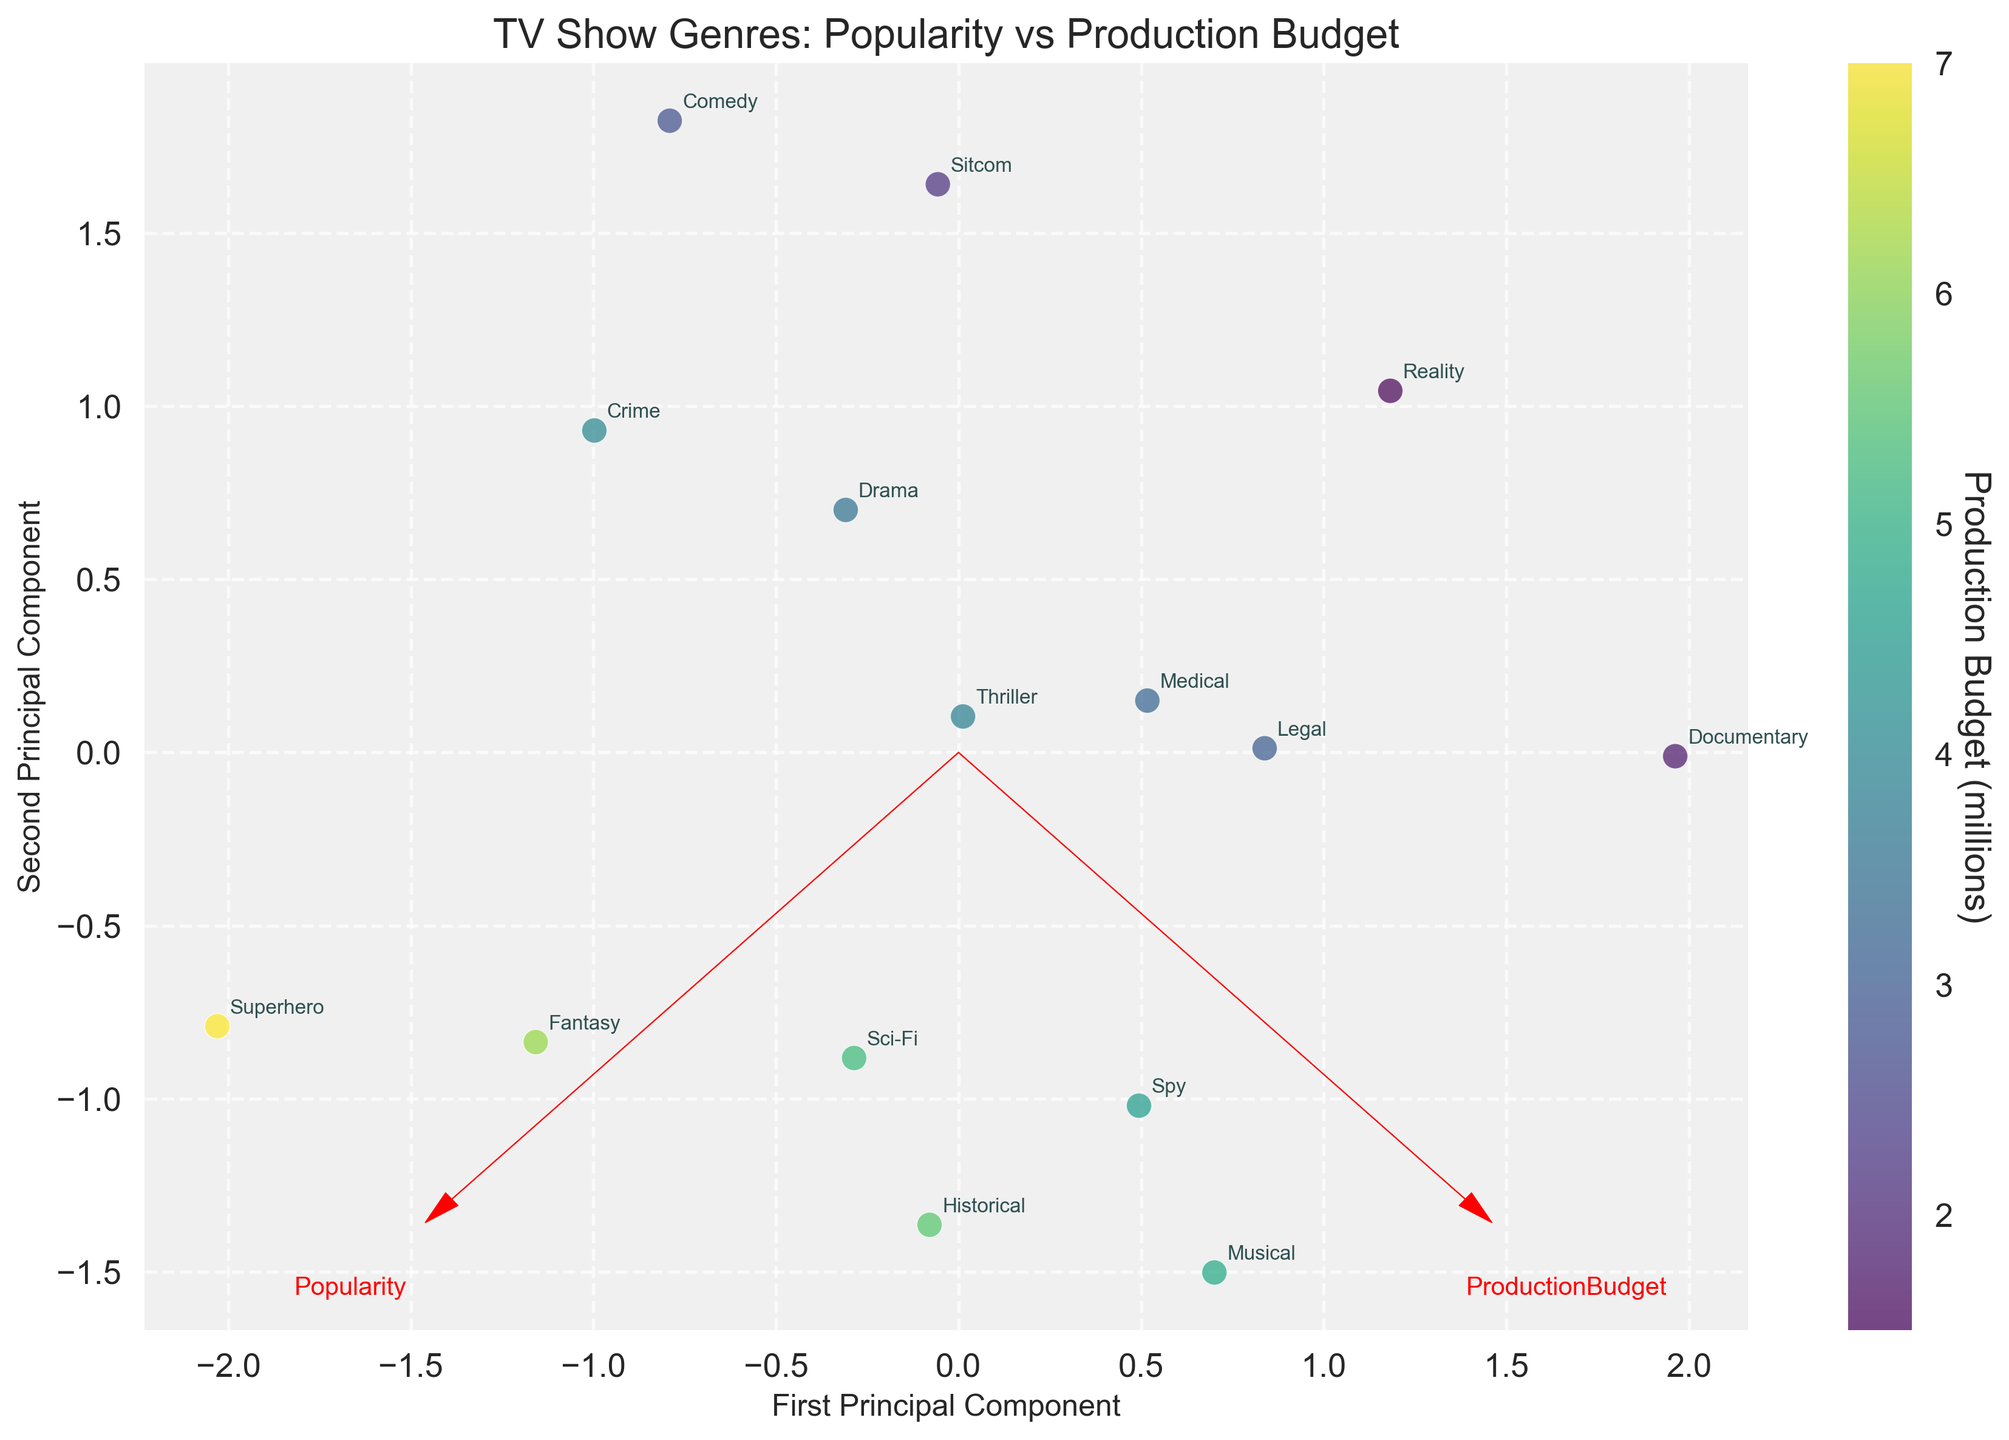What are the main axes labeled as? The first principal component is labeled along the x-axis, and the second principal component is labeled along the y-axis.
Answer: First Principal Component and Second Principal Component How many genres have a popularity above 70? The genres with a popularity above 70 can be identified by looking at their positions relative to the x-axis in the plot. If they are on the right side, they have a higher popularity score. These genres are Drama, Comedy, Crime, Sitcom, and Superhero.
Answer: 5 Which genre has the highest production budget and where is it located on the plot? The genre with the highest production budget is Superhero, which should be located far from the origin towards the direction indicated by the ProductionBudget vector's arrow.
Answer: Superhero Which genre combinations share similar principal component values? On the biplot, genres close to each other share similar principal component values. From the plot, Sitcom and Comedy are close to each other, indicating similar values.
Answer: Sitcom and Comedy Is there a noticeable trend relating production budget and popularity in the principal components? By observing the directions of the feature vectors and the clustering of points, the trend can be interpreted: genres with higher production budgets tend to be distributed similarly in the projected components compared to genres with higher popularity, but the specifics depend on the positions in the plot.
Answer: Yes, there is a trend How does the Sci-Fi genre compare to the Medical genre in terms of their location on the biplot? Sci-Fi and Medical can be compared based on their distances from the origin and each other. Sci-Fi appears further along the principal component direction of the production budget, while Medical is closer to the origin, indicating a higher budget for Sci-Fi but a lower popularity than some other genres.
Answer: Sci-Fi is higher in production budget Where is the Documentary genre located relative to the axes? Documentary is closer to the origin, indicating lower values in both principal component directions, which corresponds to lower popularity and production budget values.
Answer: Closer to the origin Which genre is most closely aligned with the direction of the Popularity vector? By visually following the direction of the Popularity arrow, the genre closest to it can be identified. In this case, Sitcom appears to align closely with the Popularity vector.
Answer: Sitcom Does the Reality genre have a higher or lower production budget compared to Drama? By looking at the positions of the Reality and Drama genres concerning the ProductionBudget vector, Reality, closer to the origin, has a lower production budget.
Answer: Lower Which genres fall under low popularity but high production budget based on the plot? Based on their positions on the biplot, genres like Historical and Fantasy, which are far along the production budget direction but closer to the origin on popularity, fit this description.
Answer: Historical and Fantasy 